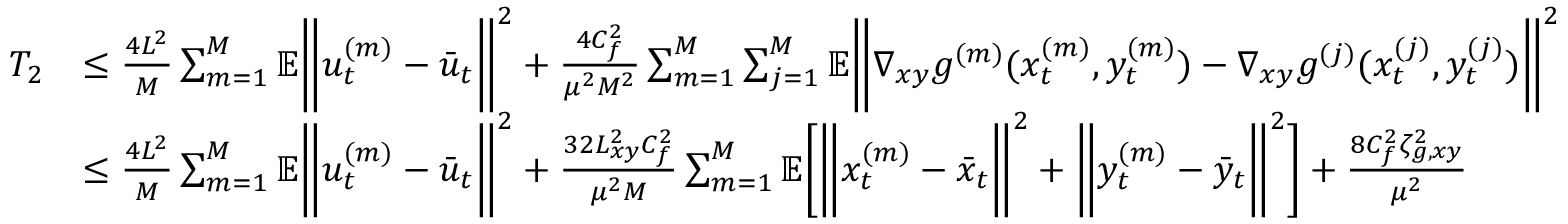<formula> <loc_0><loc_0><loc_500><loc_500>\begin{array} { r l } { T _ { 2 } } & { \leq \frac { 4 L ^ { 2 } } { M } \sum _ { m = 1 } ^ { M } \mathbb { E } \left \| u _ { t } ^ { ( m ) } - \bar { u } _ { t } \right \| ^ { 2 } + \frac { 4 C _ { f } ^ { 2 } } { \mu ^ { 2 } M ^ { 2 } } \sum _ { m = 1 } ^ { M } \sum _ { j = 1 } ^ { M } \mathbb { E } \left \| \nabla _ { x y } g ^ { ( m ) } ( x _ { t } ^ { ( m ) } , y _ { t } ^ { ( m ) } ) - \nabla _ { x y } g ^ { ( j ) } ( x _ { t } ^ { ( j ) } , y _ { t } ^ { ( j ) } ) \right \| ^ { 2 } } \\ & { \leq \frac { 4 L ^ { 2 } } { M } \sum _ { m = 1 } ^ { M } \mathbb { E } \left \| u _ { t } ^ { ( m ) } - \bar { u } _ { t } \right \| ^ { 2 } + \frac { 3 2 L _ { x y } ^ { 2 } C _ { f } ^ { 2 } } { \mu ^ { 2 } M } \sum _ { m = 1 } ^ { M } \mathbb { E } \left [ \left \| x _ { t } ^ { ( m ) } - \bar { x } _ { t } \right \| ^ { 2 } + \left \| y _ { t } ^ { ( m ) } - \bar { y } _ { t } \right \| ^ { 2 } \right ] + \frac { 8 C _ { f } ^ { 2 } \zeta _ { g , x y } ^ { 2 } } { \mu ^ { 2 } } } \end{array}</formula> 